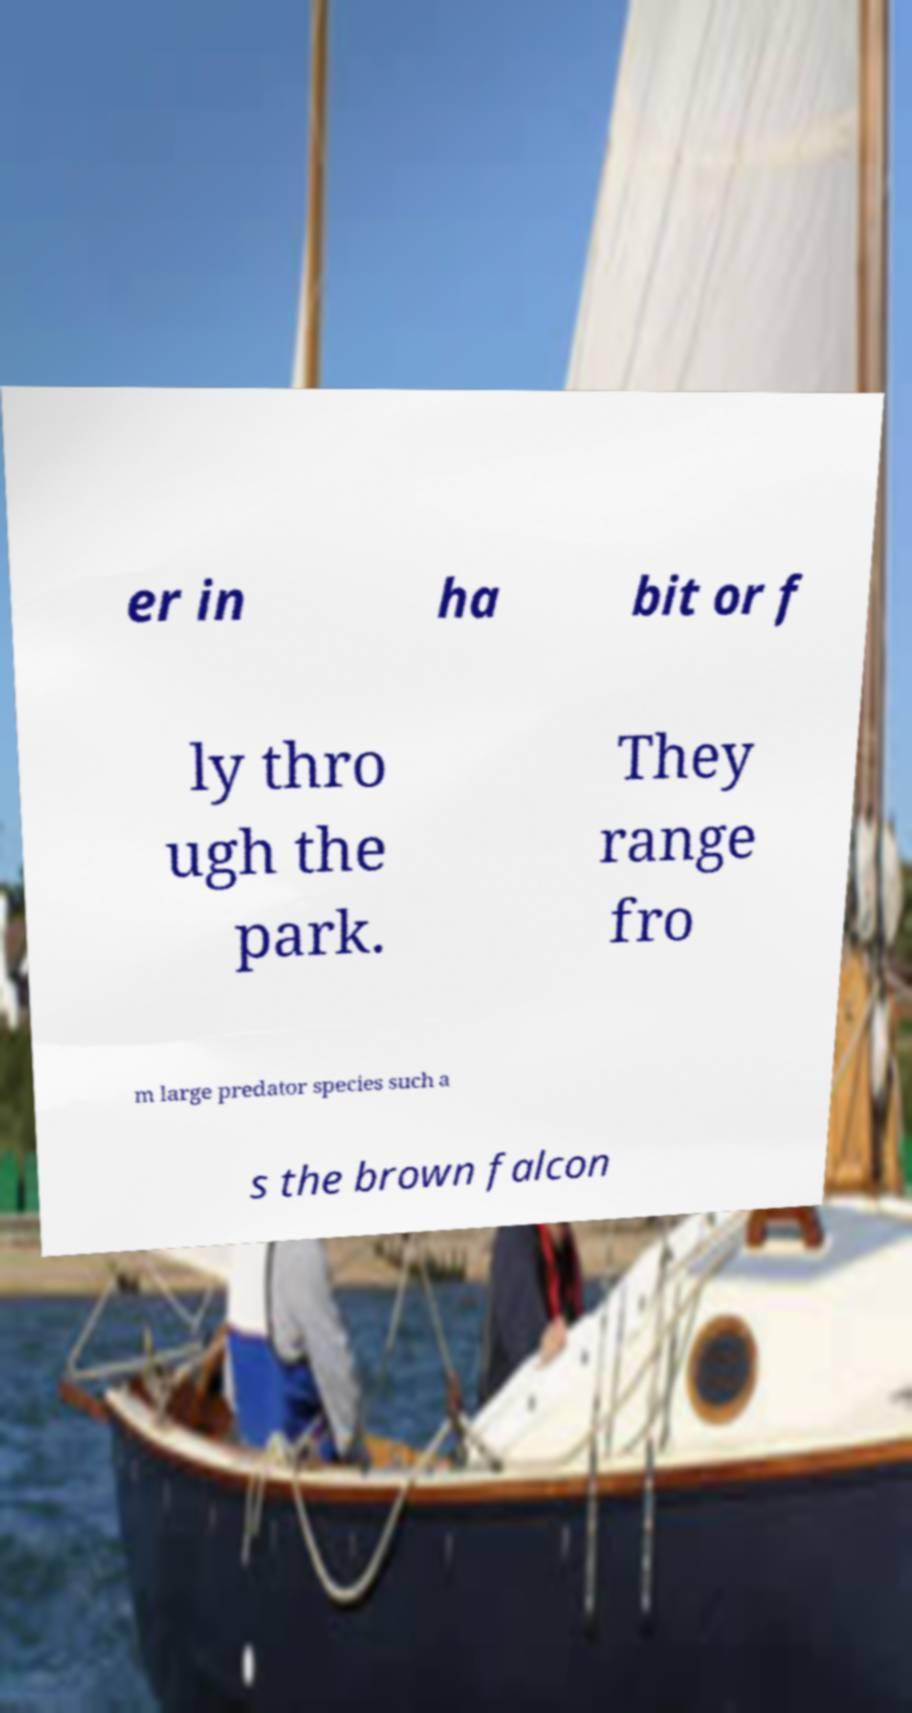Could you assist in decoding the text presented in this image and type it out clearly? er in ha bit or f ly thro ugh the park. They range fro m large predator species such a s the brown falcon 